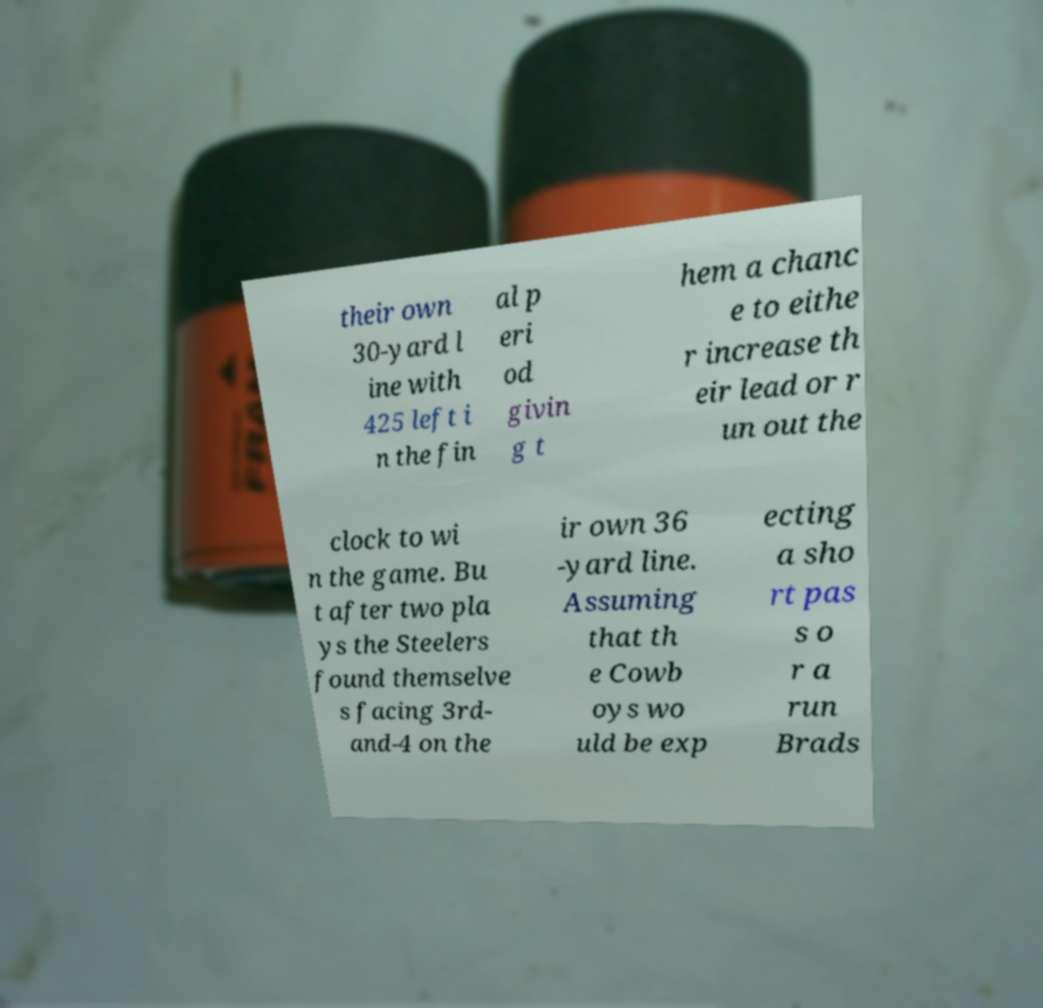For documentation purposes, I need the text within this image transcribed. Could you provide that? their own 30-yard l ine with 425 left i n the fin al p eri od givin g t hem a chanc e to eithe r increase th eir lead or r un out the clock to wi n the game. Bu t after two pla ys the Steelers found themselve s facing 3rd- and-4 on the ir own 36 -yard line. Assuming that th e Cowb oys wo uld be exp ecting a sho rt pas s o r a run Brads 